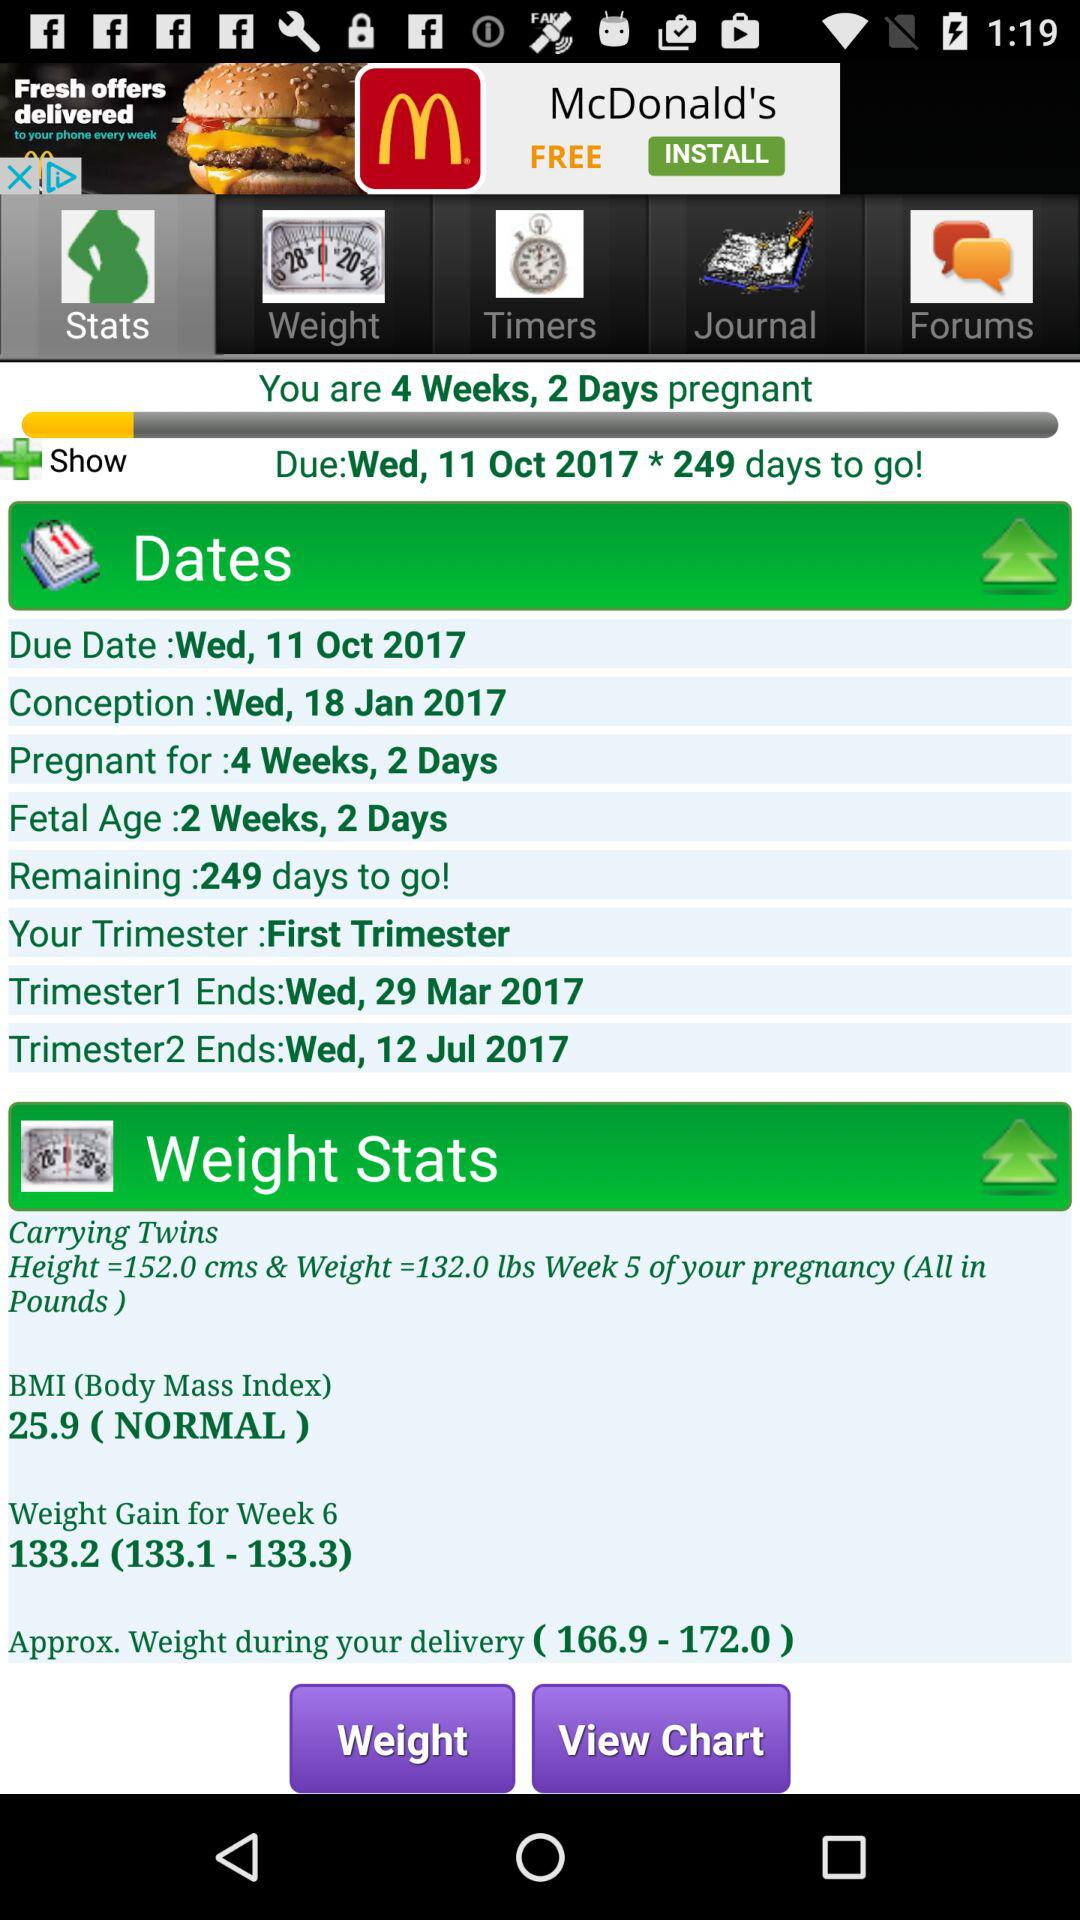What is the Body Mass Index?
Answer the question using a single word or phrase. It is 25.9. 